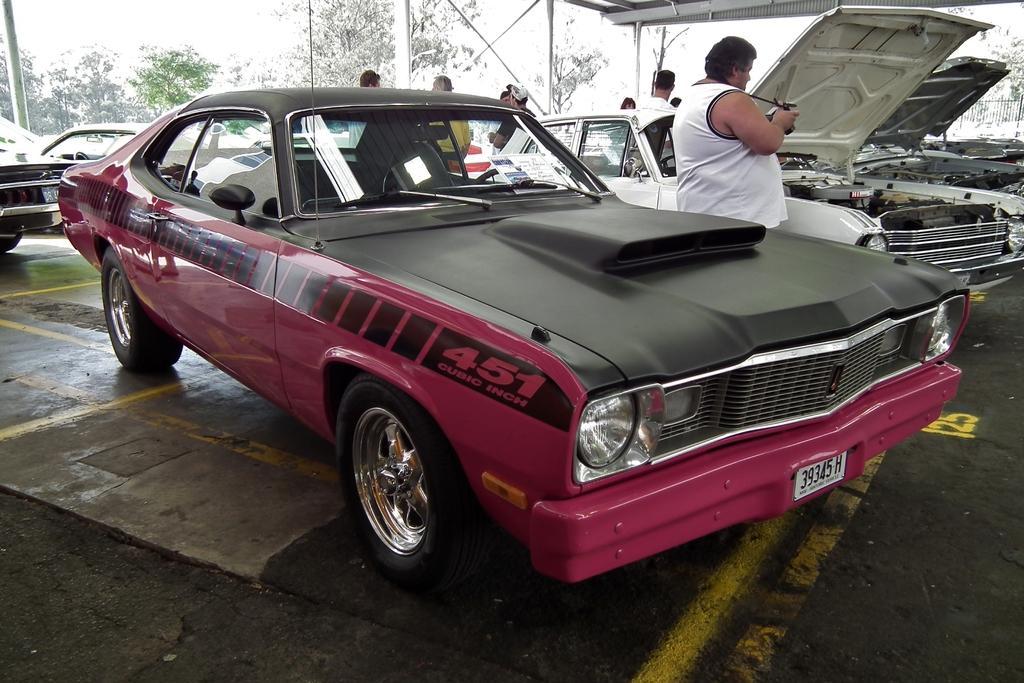Can you describe this image briefly? In this image I can see few vehicles, in front the vehicle is in black and pink color. I can also see a person standing wearing white shirt, background I can see few trees in green color and sky in white color. 